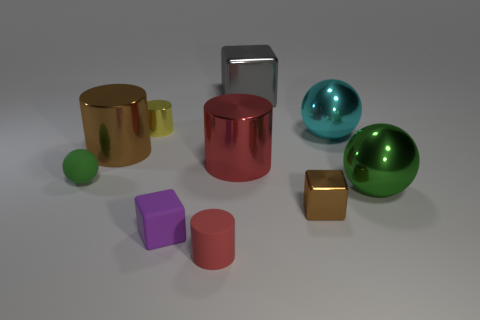Are there any objects that stand out due to their size? Yes, the large brown shiny cylinder is the most dominant object due to its size and central placement within the composition. There is also a notable contrast in size when comparing the small pink cube and the large brown cylinder. 